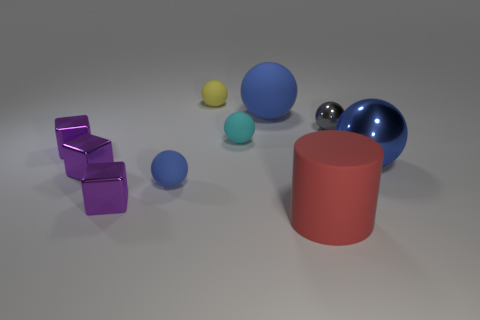Subtract all cyan cubes. How many blue spheres are left? 3 Subtract all yellow matte spheres. How many spheres are left? 5 Subtract all yellow spheres. How many spheres are left? 5 Subtract all green spheres. Subtract all purple cylinders. How many spheres are left? 6 Subtract all cylinders. How many objects are left? 9 Subtract 0 purple cylinders. How many objects are left? 10 Subtract all small metal cylinders. Subtract all gray shiny spheres. How many objects are left? 9 Add 3 yellow spheres. How many yellow spheres are left? 4 Add 8 big cylinders. How many big cylinders exist? 9 